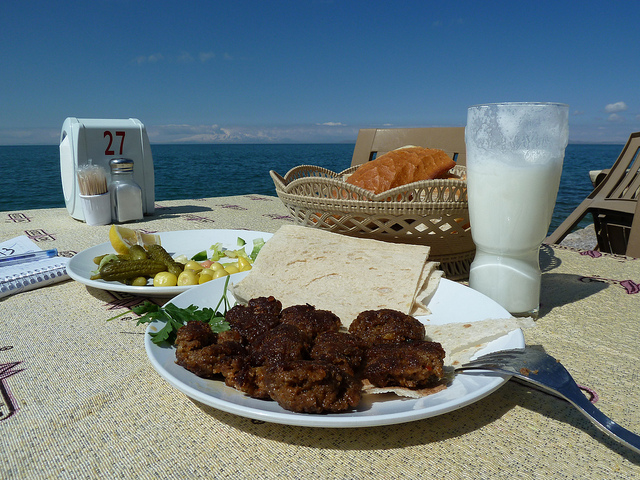Why would someone be seated here? A person might be seated here to enjoy a meal with a scenic view of the ocean, basking in the serene ambiance and possibly savoring the pleasant weather. It's an ideal spot for a relaxing and refreshing dining experience. 